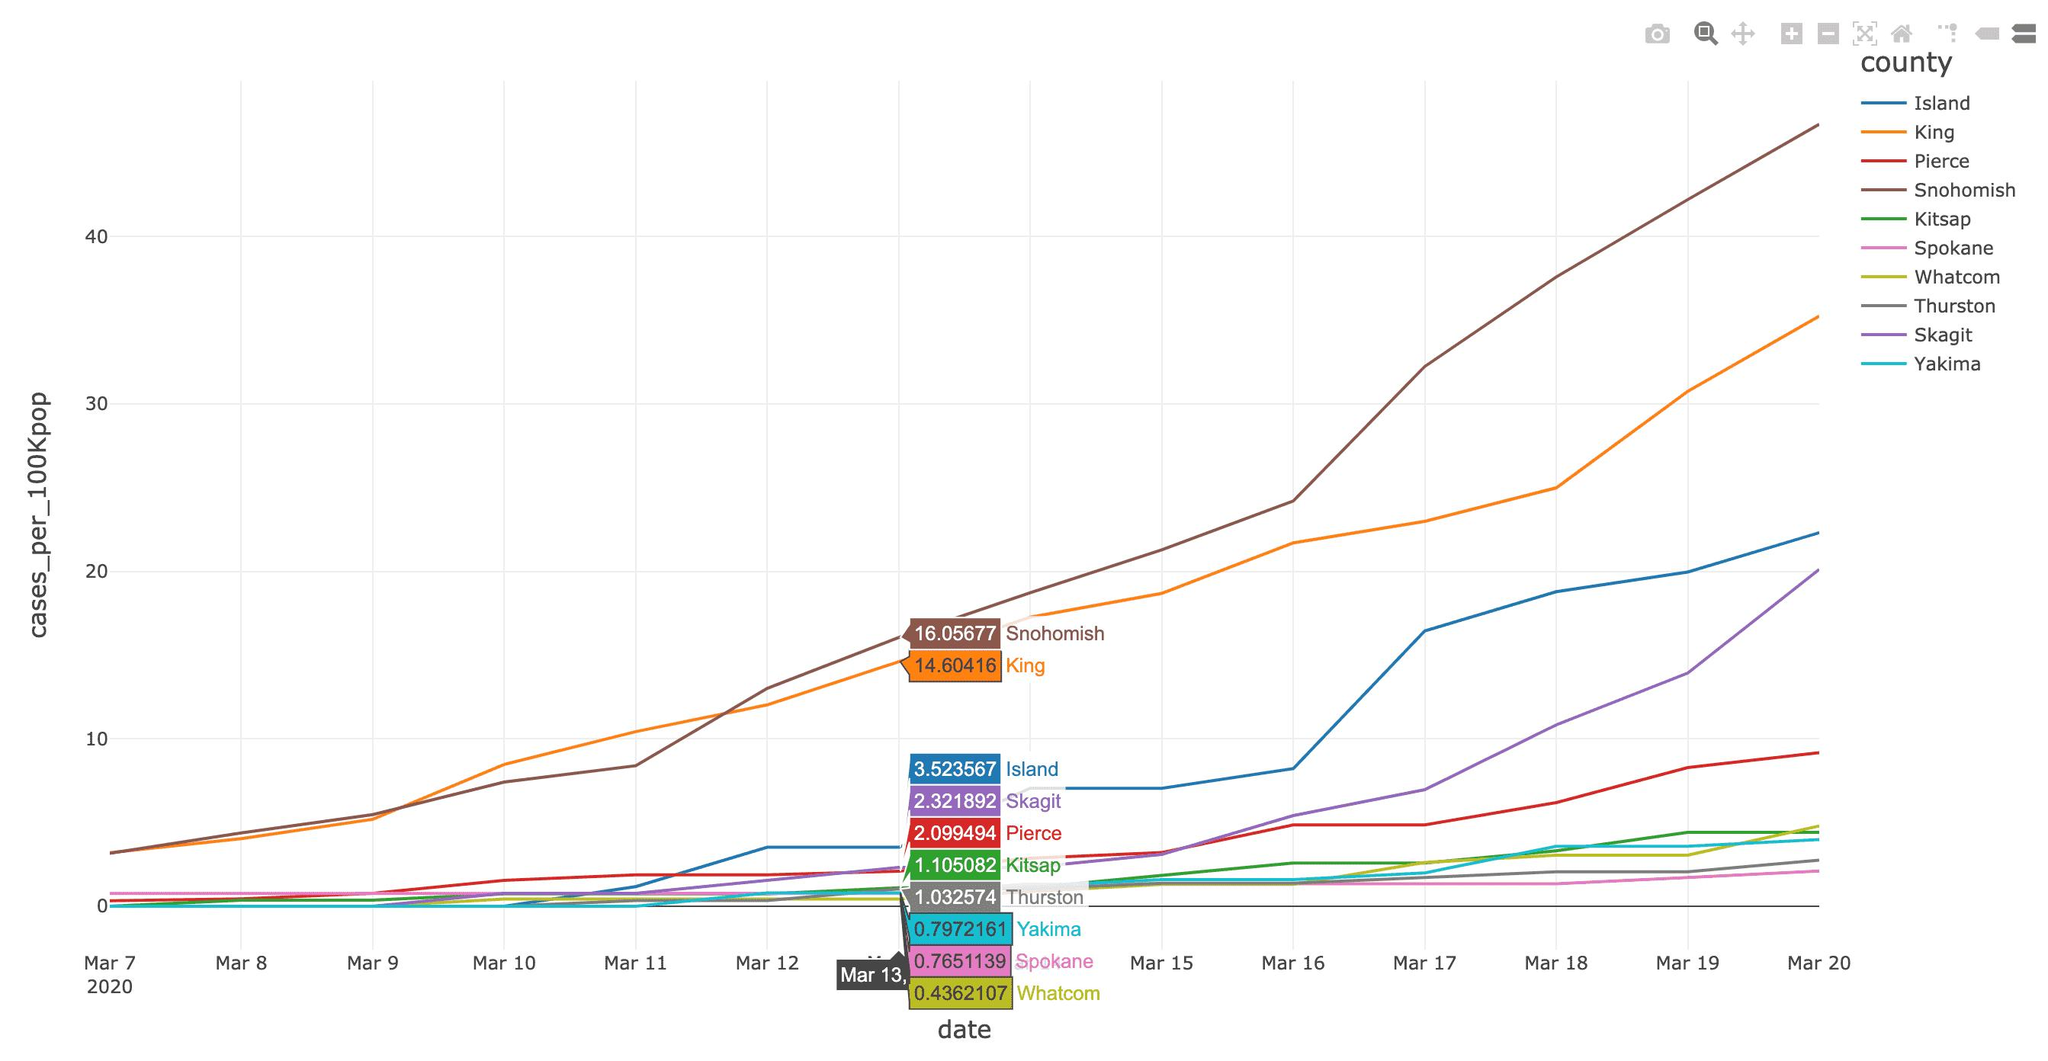Identify some key points in this picture. The color code given to the King is yellow, red, green, and orange. The color code given to the King is orange. On March 11, the region with the highest number of reported cases per 100,000 population was [King]. The difference between the cases in Snohomish and King is 1.45261... The number of cases in the orange-colored region is 14.60416... Spokane is the region with the second lowest number of cases reported per 100,000 population. 